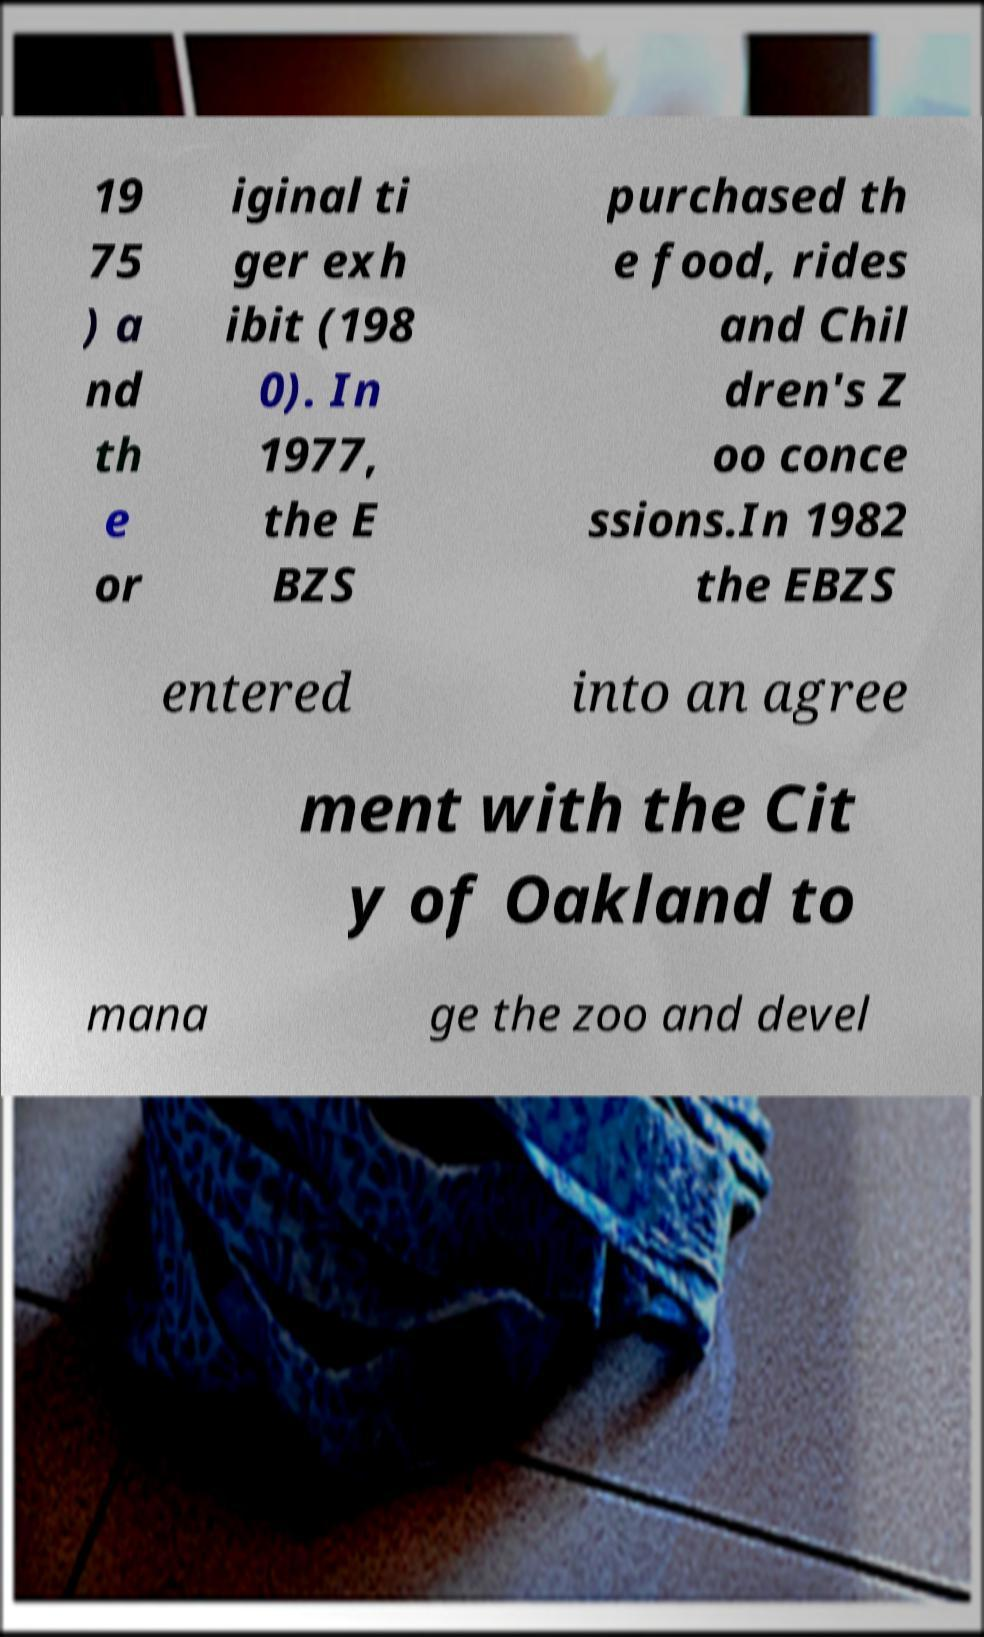Please read and relay the text visible in this image. What does it say? 19 75 ) a nd th e or iginal ti ger exh ibit (198 0). In 1977, the E BZS purchased th e food, rides and Chil dren's Z oo conce ssions.In 1982 the EBZS entered into an agree ment with the Cit y of Oakland to mana ge the zoo and devel 